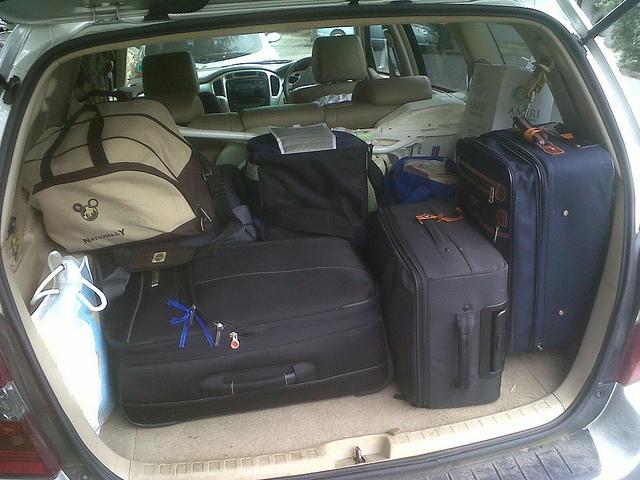What video game does the organization of these bags resemble?
Be succinct. Tetris. What is placed in the boot of the car?
Answer briefly. Luggage. What color is the cardboard box?
Be succinct. White. 